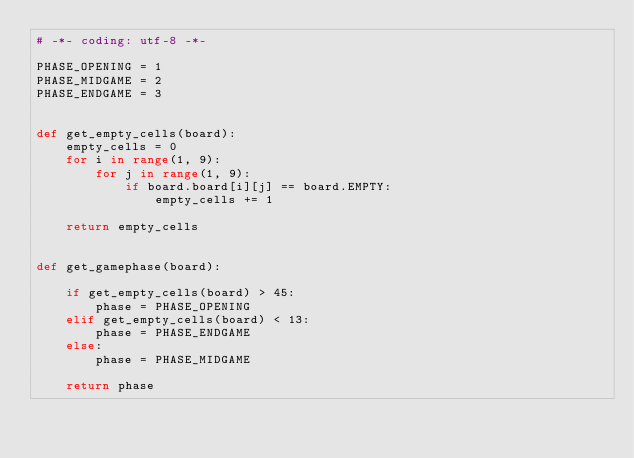<code> <loc_0><loc_0><loc_500><loc_500><_Python_># -*- coding: utf-8 -*-

PHASE_OPENING = 1
PHASE_MIDGAME = 2
PHASE_ENDGAME = 3


def get_empty_cells(board):
    empty_cells = 0
    for i in range(1, 9):
        for j in range(1, 9):
            if board.board[i][j] == board.EMPTY:
                empty_cells += 1

    return empty_cells


def get_gamephase(board):

    if get_empty_cells(board) > 45:
        phase = PHASE_OPENING
    elif get_empty_cells(board) < 13:
        phase = PHASE_ENDGAME
    else:
        phase = PHASE_MIDGAME

    return phase
</code> 